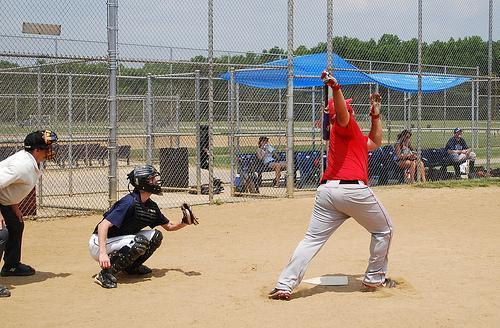How many umpires are there?
Give a very brief answer. 1. 